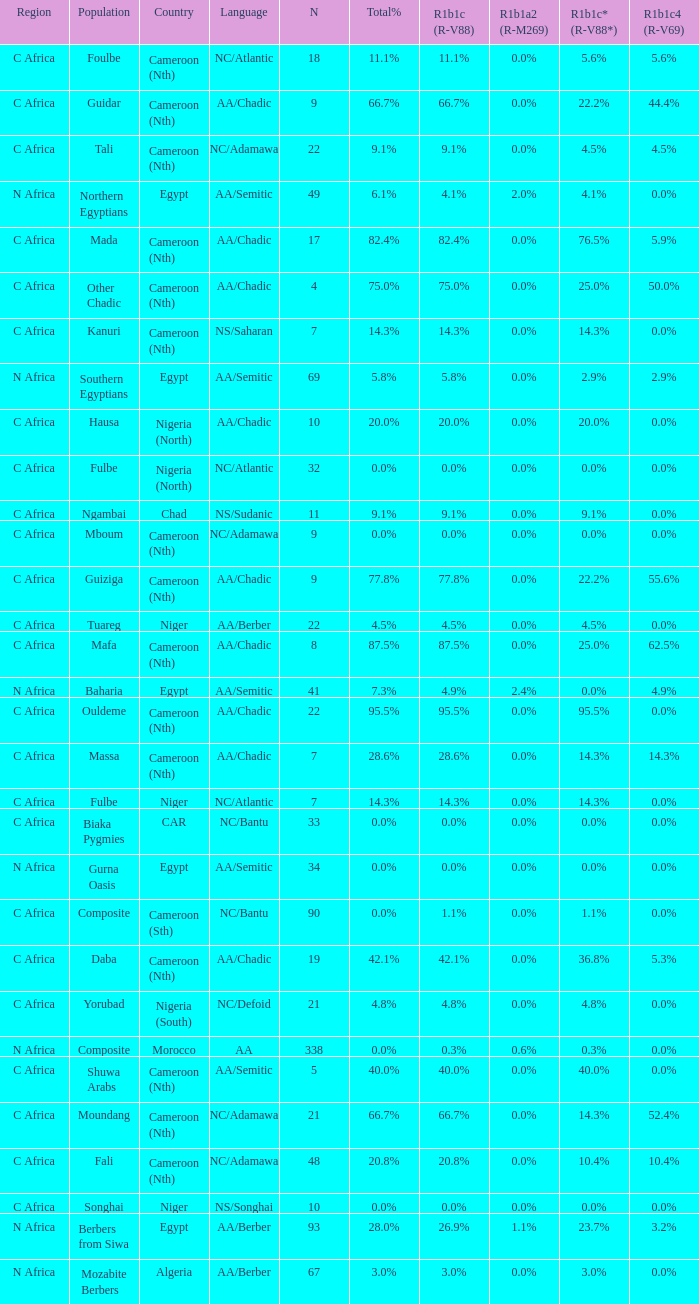What is the largest n value for 55.6% r1b1c4 (r-v69)? 9.0. 